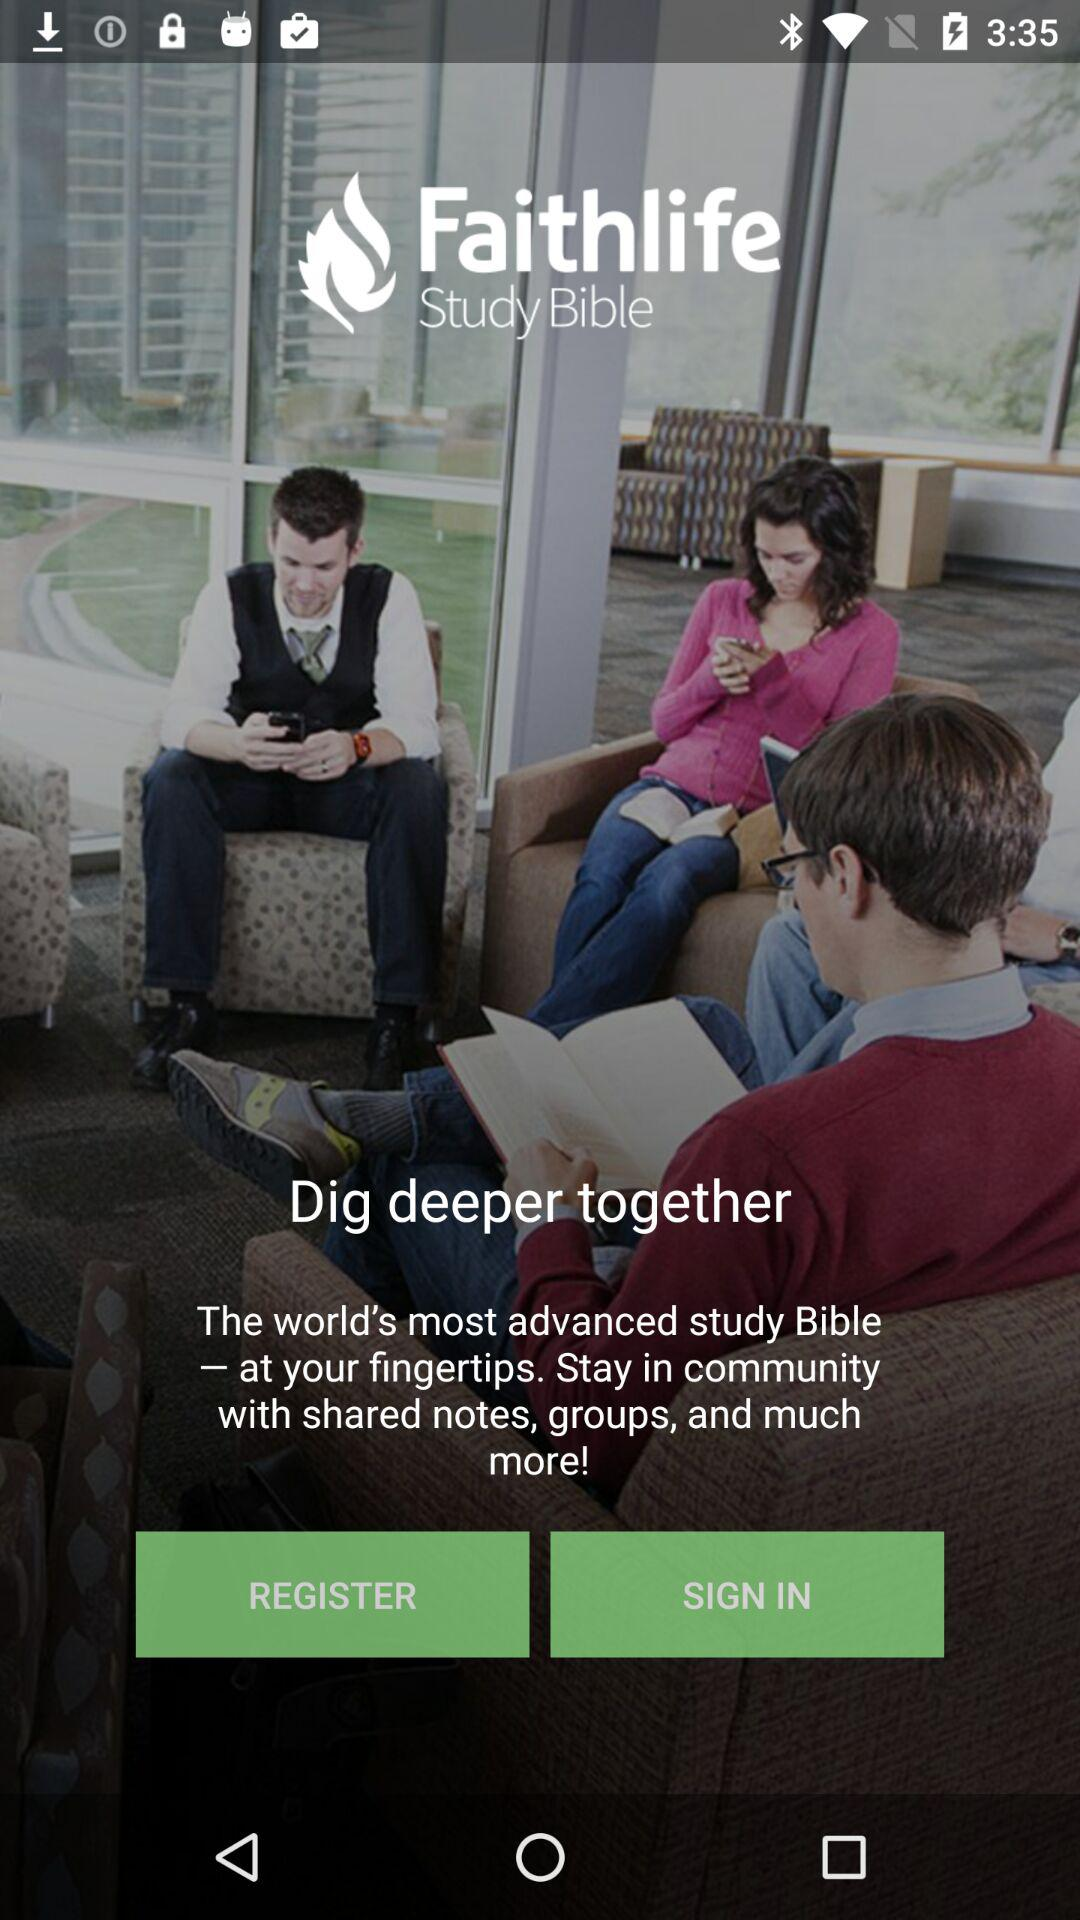What is the app's name? The app's name is "Faithlife". 